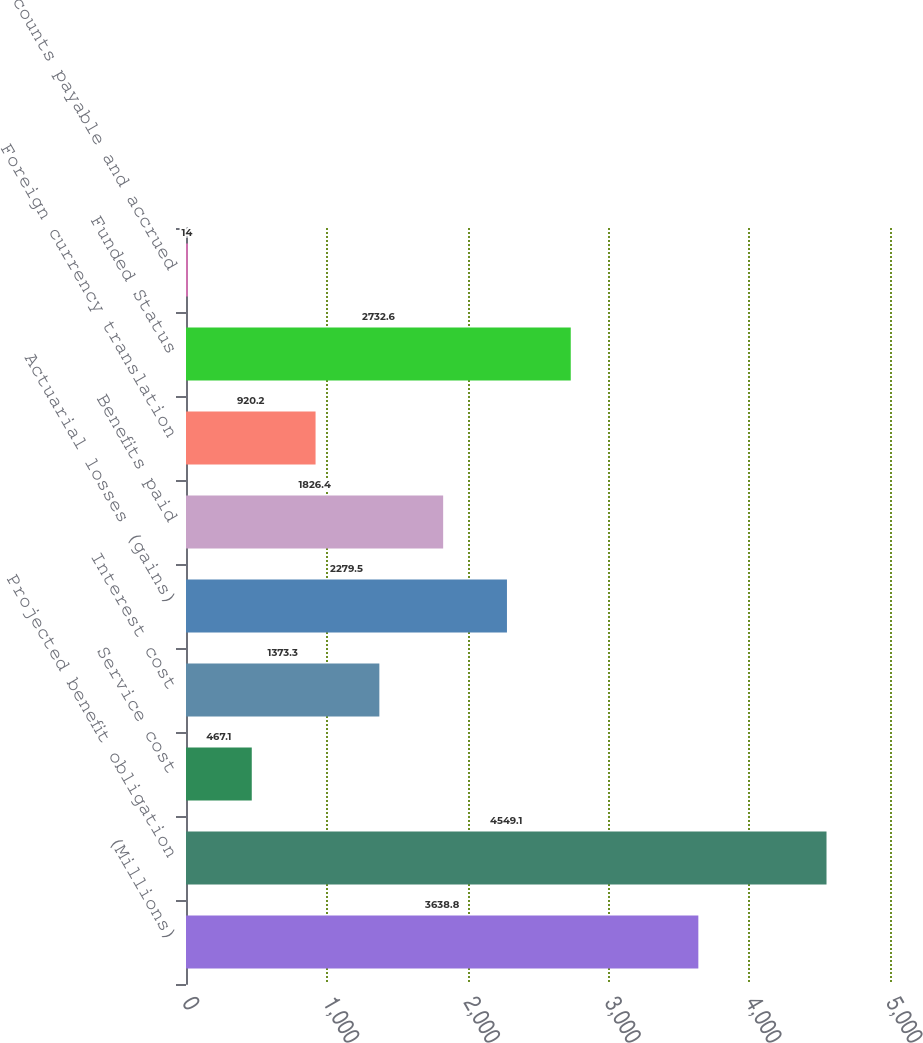Convert chart to OTSL. <chart><loc_0><loc_0><loc_500><loc_500><bar_chart><fcel>(Millions)<fcel>Projected benefit obligation<fcel>Service cost<fcel>Interest cost<fcel>Actuarial losses (gains)<fcel>Benefits paid<fcel>Foreign currency translation<fcel>Funded Status<fcel>Accounts payable and accrued<nl><fcel>3638.8<fcel>4549.1<fcel>467.1<fcel>1373.3<fcel>2279.5<fcel>1826.4<fcel>920.2<fcel>2732.6<fcel>14<nl></chart> 